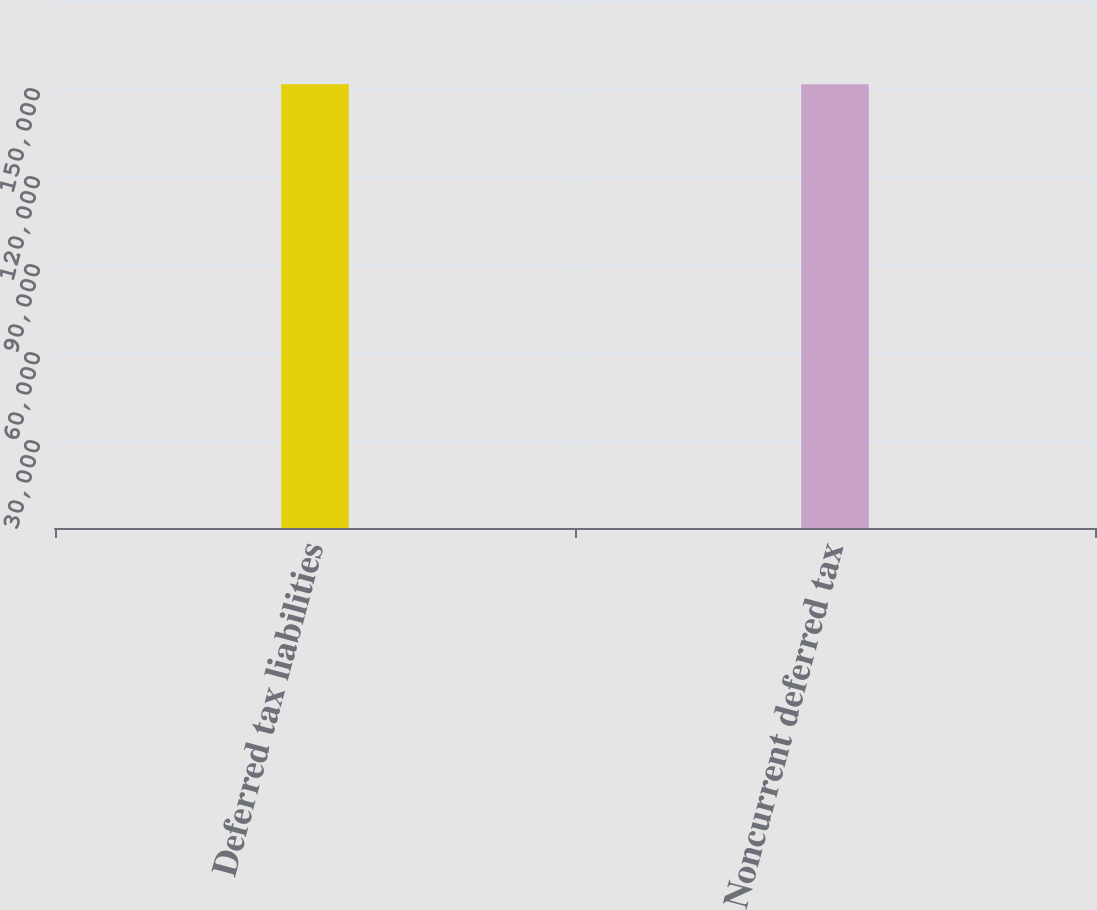Convert chart. <chart><loc_0><loc_0><loc_500><loc_500><bar_chart><fcel>Deferred tax liabilities<fcel>Noncurrent deferred tax<nl><fcel>151295<fcel>151295<nl></chart> 